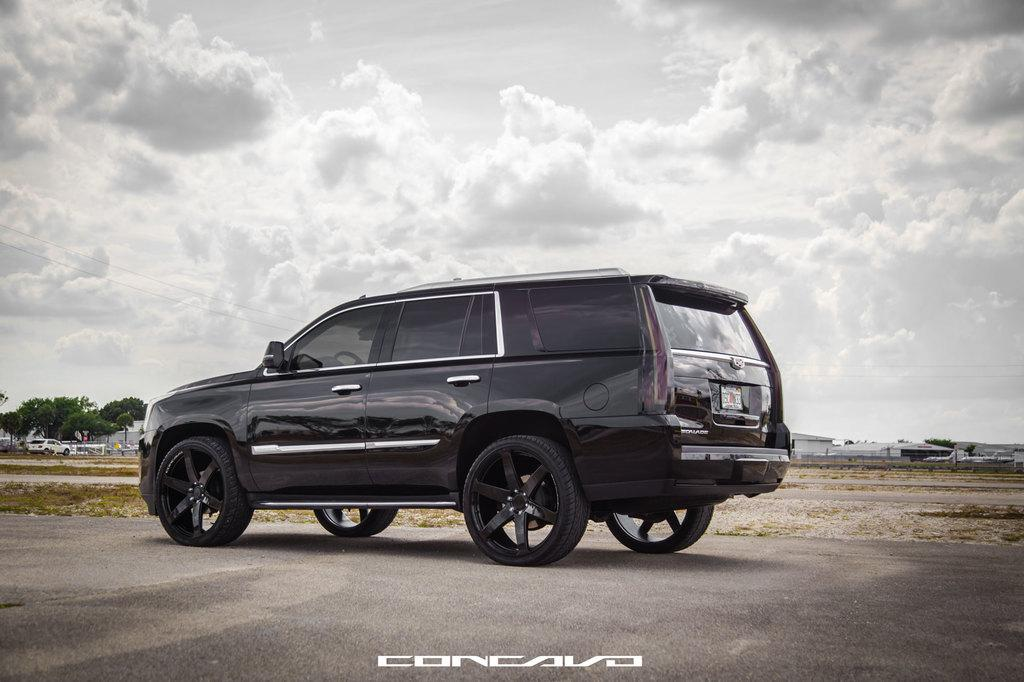What is located at the bottom of the image? There is a road at the bottom of the image. What can be seen in the middle of the image? There is a car in the middle of the image. What type of vegetation is present in the center of the image? Grass is present in the center of the image. What structures are visible in the center of the image? Buildings are visible in the center of the image. What else is present in the center of the image? Trees and various objects are present in the center of the image. What is visible at the top of the image? The sky is visible at the top of the image. What type of credit card is being used to plough the field in the image? There is no credit card or ploughing activity present in the image. What form does the car take in the image? The car is depicted in its typical form as a vehicle for transportation. 